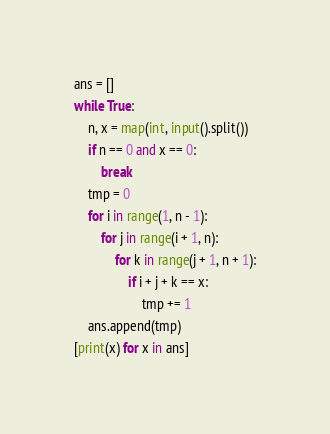Convert code to text. <code><loc_0><loc_0><loc_500><loc_500><_Python_>ans = []
while True:
    n, x = map(int, input().split())
    if n == 0 and x == 0:
        break
    tmp = 0
    for i in range(1, n - 1):
        for j in range(i + 1, n):
            for k in range(j + 1, n + 1):
                if i + j + k == x:
                    tmp += 1
    ans.append(tmp)
[print(x) for x in ans]

</code> 